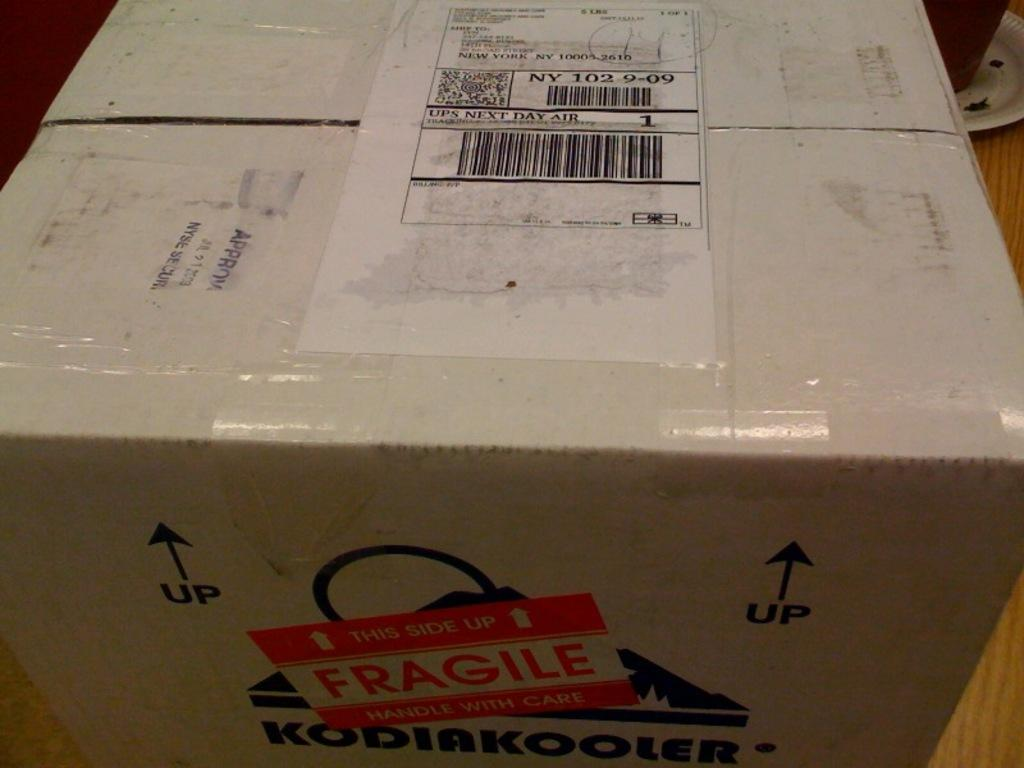<image>
Summarize the visual content of the image. A box with a FRAGILE sticker on it from KODIAKOOLER. 